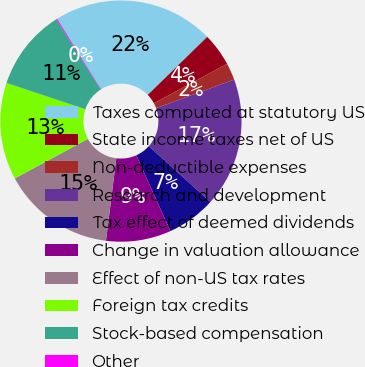<chart> <loc_0><loc_0><loc_500><loc_500><pie_chart><fcel>Taxes computed at statutory US<fcel>State income taxes net of US<fcel>Non-deductible expenses<fcel>Research and development<fcel>Tax effect of deemed dividends<fcel>Change in valuation allowance<fcel>Effect of non-US tax rates<fcel>Foreign tax credits<fcel>Stock-based compensation<fcel>Other<nl><fcel>21.57%<fcel>4.43%<fcel>2.28%<fcel>17.29%<fcel>6.57%<fcel>8.71%<fcel>15.14%<fcel>13.0%<fcel>10.86%<fcel>0.14%<nl></chart> 